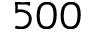Convert formula to latex. <formula><loc_0><loc_0><loc_500><loc_500>5 0 0</formula> 